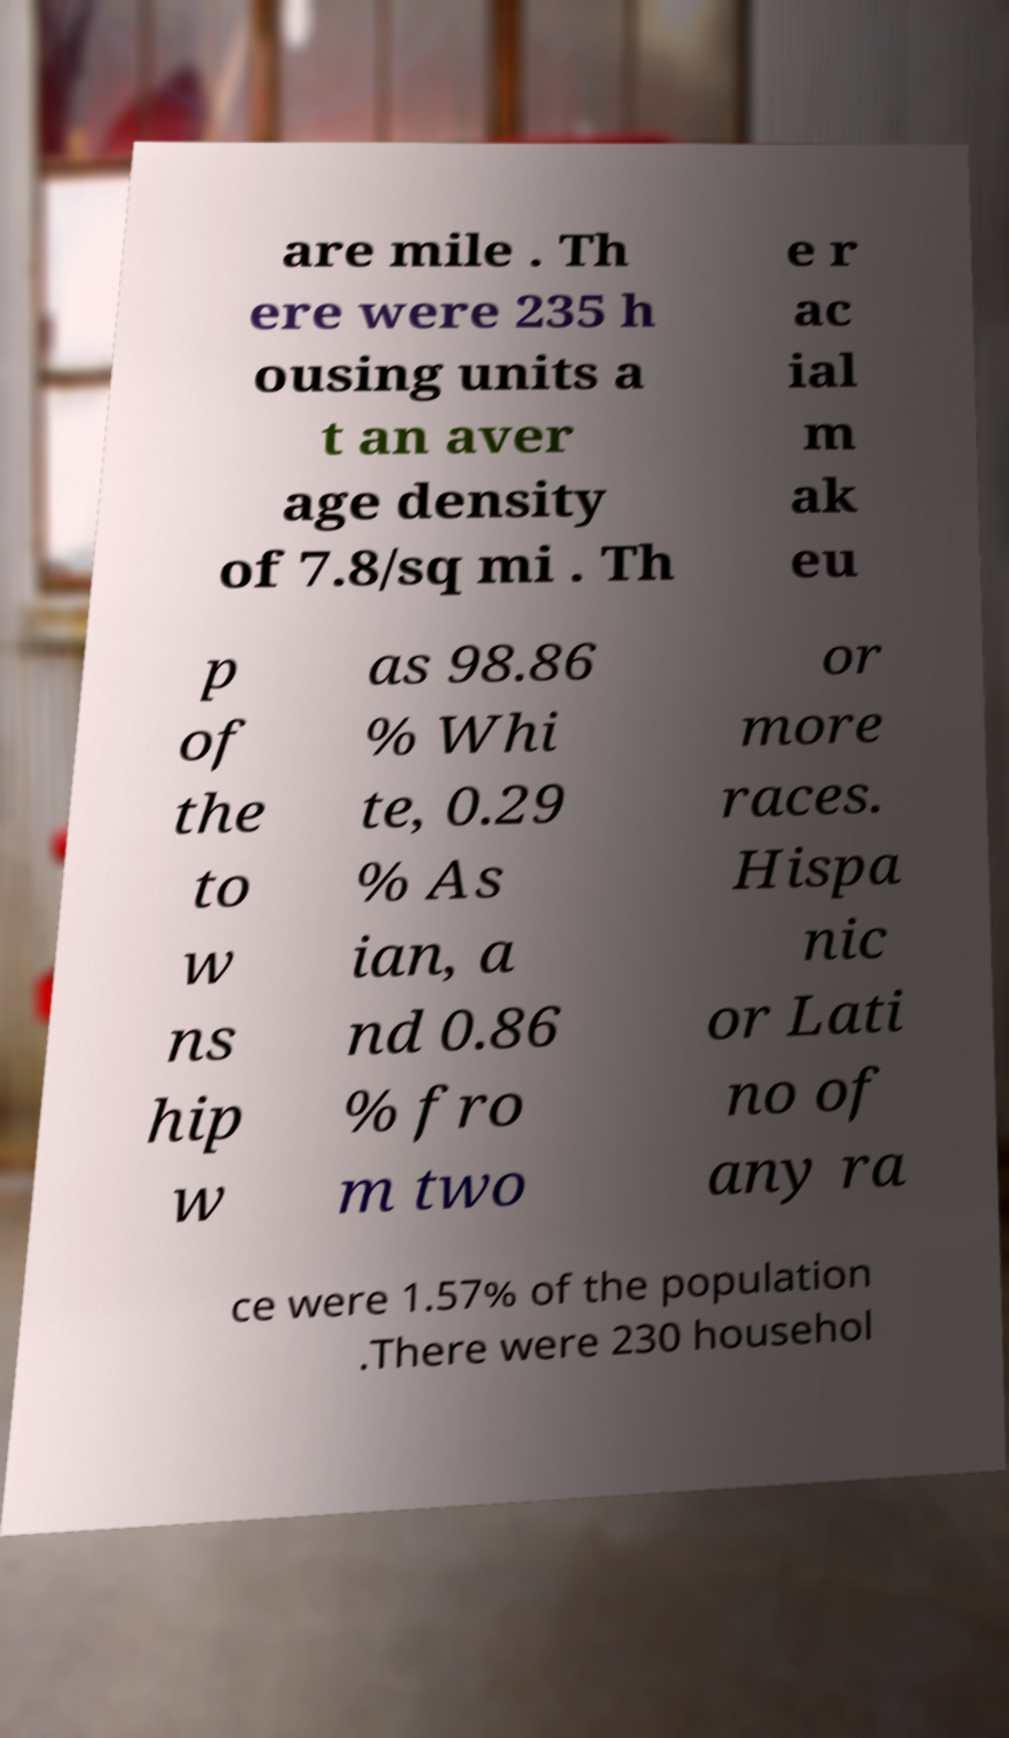For documentation purposes, I need the text within this image transcribed. Could you provide that? are mile . Th ere were 235 h ousing units a t an aver age density of 7.8/sq mi . Th e r ac ial m ak eu p of the to w ns hip w as 98.86 % Whi te, 0.29 % As ian, a nd 0.86 % fro m two or more races. Hispa nic or Lati no of any ra ce were 1.57% of the population .There were 230 househol 